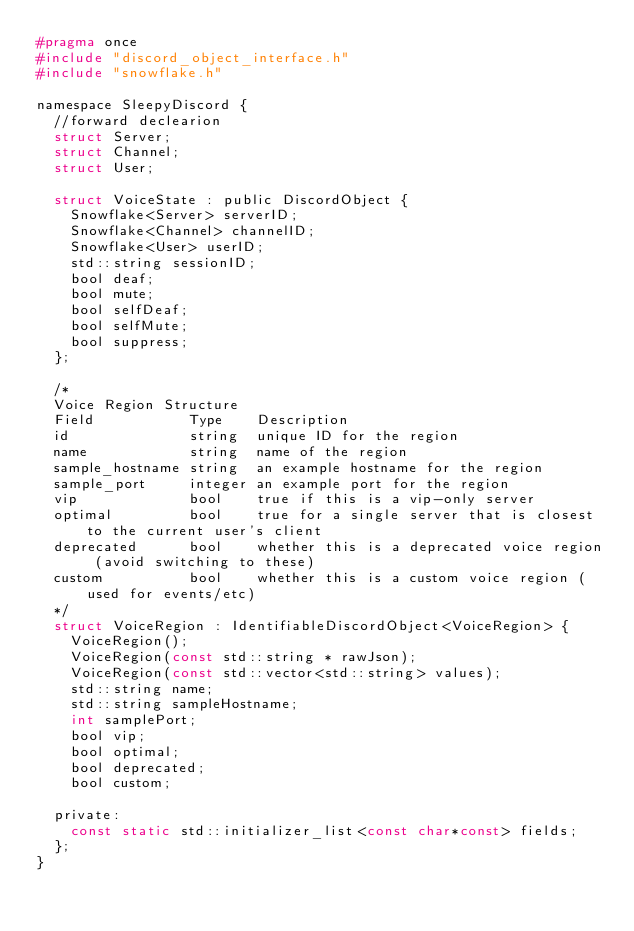<code> <loc_0><loc_0><loc_500><loc_500><_C_>#pragma once
#include "discord_object_interface.h"
#include "snowflake.h"

namespace SleepyDiscord {
	//forward declearion
	struct Server;
	struct Channel;
	struct User;

	struct VoiceState : public DiscordObject {
		Snowflake<Server> serverID;
		Snowflake<Channel> channelID;
		Snowflake<User> userID;
		std::string sessionID;
		bool deaf;
		bool mute;
		bool selfDeaf;
		bool selfMute;
		bool suppress;
	};

	/*
	Voice Region Structure
	Field           Type    Description
	id              string  unique ID for the region
	name            string  name of the region
	sample_hostname string  an example hostname for the region
	sample_port     integer an example port for the region
	vip             bool    true if this is a vip-only server
	optimal         bool    true for a single server that is closest to the current user's client
	deprecated      bool    whether this is a deprecated voice region (avoid switching to these)
	custom          bool    whether this is a custom voice region (used for events/etc)
	*/
	struct VoiceRegion : IdentifiableDiscordObject<VoiceRegion> {
		VoiceRegion();
		VoiceRegion(const std::string * rawJson);
		VoiceRegion(const std::vector<std::string> values);
		std::string name;
		std::string sampleHostname;
		int samplePort;
		bool vip;
		bool optimal;
		bool deprecated;
		bool custom;

	private:
		const static std::initializer_list<const char*const> fields;
	};
}</code> 